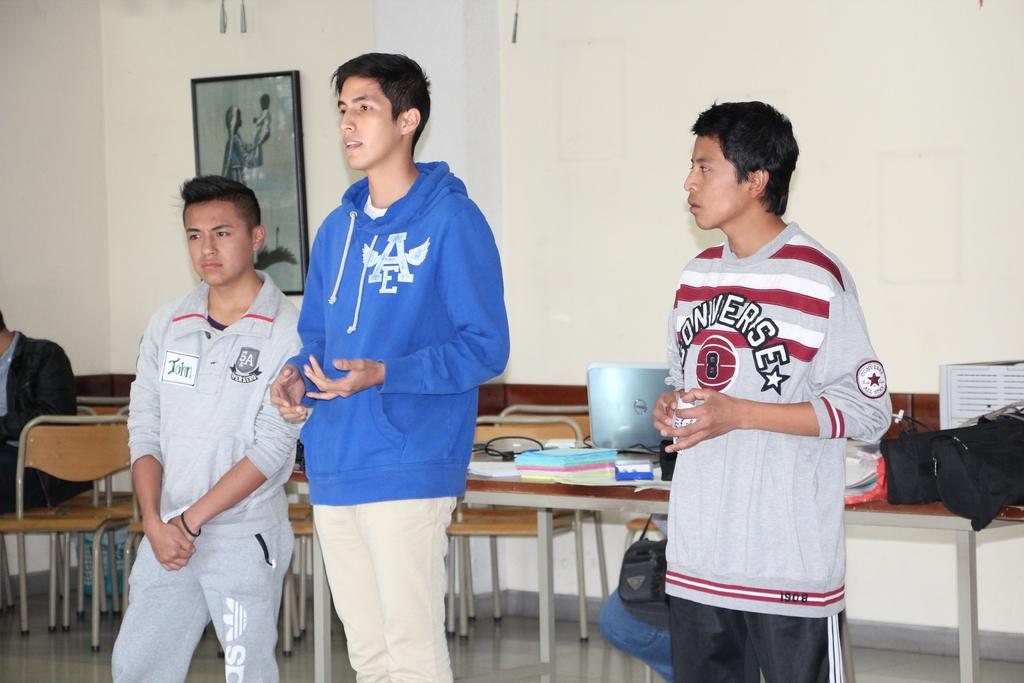What letter is on the shirt in blue?
Offer a very short reply. Ae. 